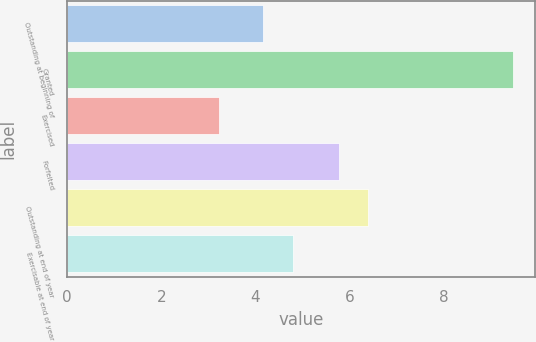Convert chart to OTSL. <chart><loc_0><loc_0><loc_500><loc_500><bar_chart><fcel>Outstanding at beginning of<fcel>Granted<fcel>Exercised<fcel>Forfeited<fcel>Outstanding at end of year<fcel>Exercisable at end of year<nl><fcel>4.17<fcel>9.48<fcel>3.22<fcel>5.77<fcel>6.4<fcel>4.8<nl></chart> 